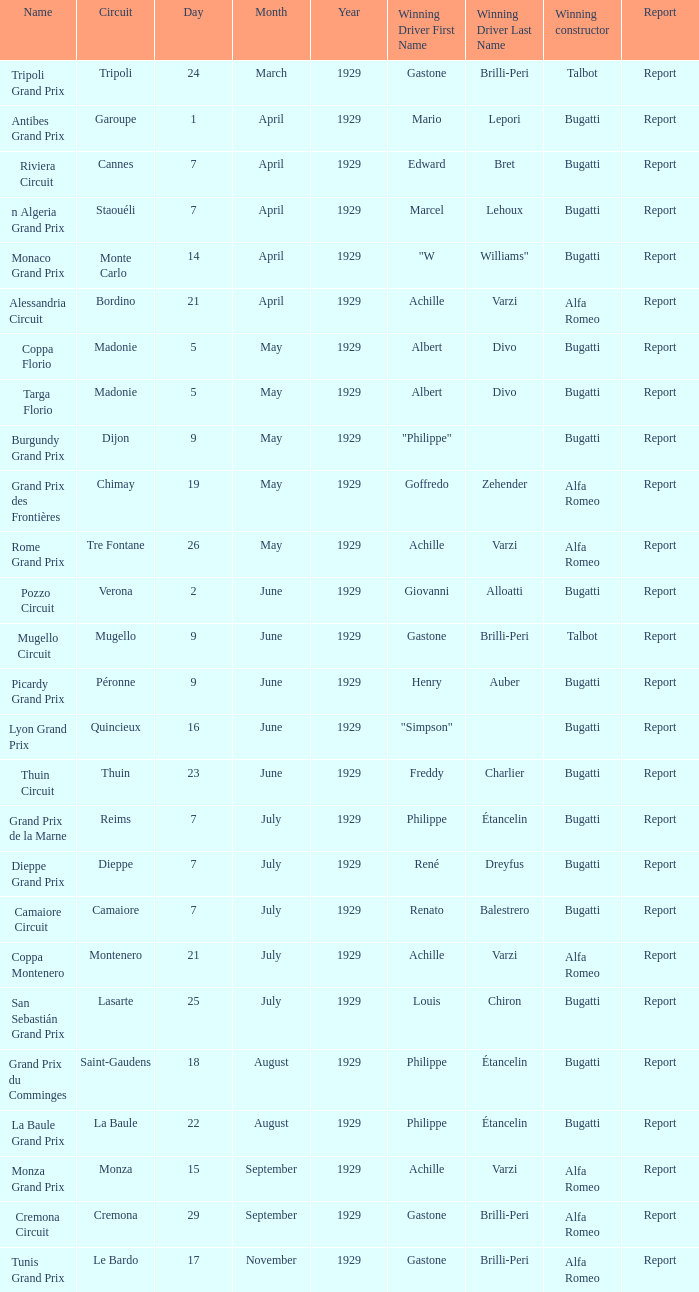Which victorious driver is named after the mugello circuit? Gastone Brilli-Peri. 